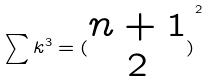Convert formula to latex. <formula><loc_0><loc_0><loc_500><loc_500>\sum k ^ { 3 } = { ( \begin{matrix} n + 1 \\ 2 \end{matrix} ) } ^ { 2 }</formula> 